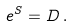<formula> <loc_0><loc_0><loc_500><loc_500>e ^ { S } = D \, .</formula> 